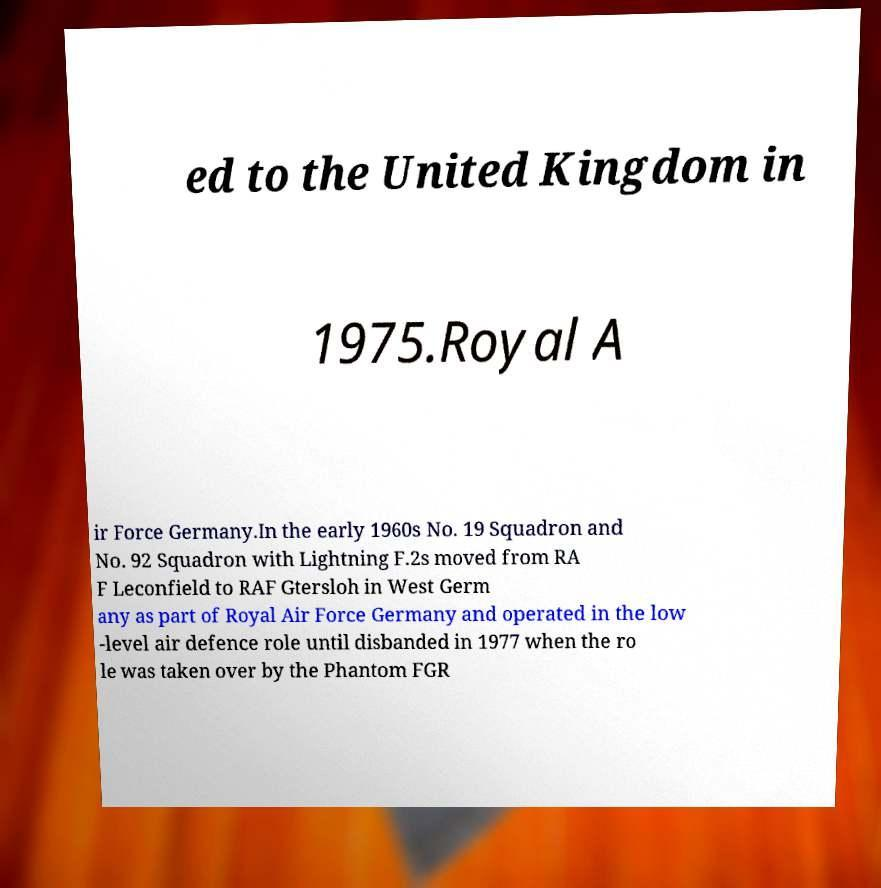I need the written content from this picture converted into text. Can you do that? ed to the United Kingdom in 1975.Royal A ir Force Germany.In the early 1960s No. 19 Squadron and No. 92 Squadron with Lightning F.2s moved from RA F Leconfield to RAF Gtersloh in West Germ any as part of Royal Air Force Germany and operated in the low -level air defence role until disbanded in 1977 when the ro le was taken over by the Phantom FGR 